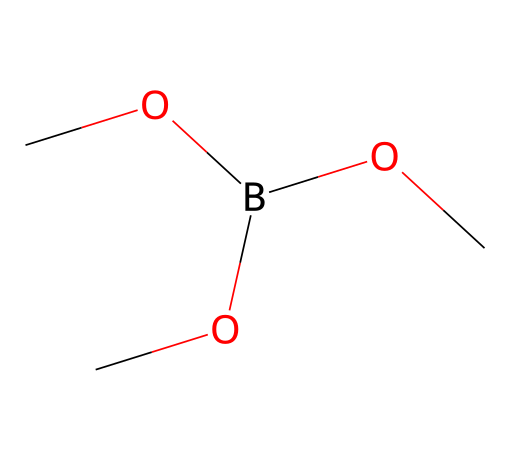How many carbon atoms are in trimethyl borate? In the SMILES representation, "C" represents carbon atoms, and there are three "C" present in the structure, indicating three carbon atoms.
Answer: 3 What type of bonds connect the carbon atoms to the boron atom in trimethyl borate? The structure represents three methoxy groups (OC) connected to boron (B). Each carbon in the methoxy group is connected to the boron atom through a single covalent bond.
Answer: single covalent bonds What is the molecular formula of trimethyl borate? By interpreting the SMILES, we can deduce the presence of three carbon (C), nine hydrogen (H from three methoxy groups), and one boron (B) atom. Thus, the molecular formula becomes C3H9BO3.
Answer: C3H9BO3 What are the functional groups present in trimethyl borate? The presence of -OCH3 groups in the structure indicates that the functional groups present are methoxy groups (-OCH3). There are three such functional groups.
Answer: methoxy groups Is trimethyl borate a saturated or unsaturated compound? The structure shows that all carbon atoms in the methoxy groups are connected to hydrogen atoms and do not have any double or triple bonds. Therefore, trimethyl borate is classified as a saturated compound.
Answer: saturated What type of chemical is trimethyl borate classified as? Trimethyl borate consists primarily of carbon, hydrogen, and boron elements. It is classified as an organoboron compound due to the presence of boron bound to carbon-containing groups.
Answer: organoboron Why is trimethyl borate used in fireworks displays? The presence of boron in the compound is responsible for the production of a green flame color when it is burned, making it suitable for fireworks displays.
Answer: green flame colorant 